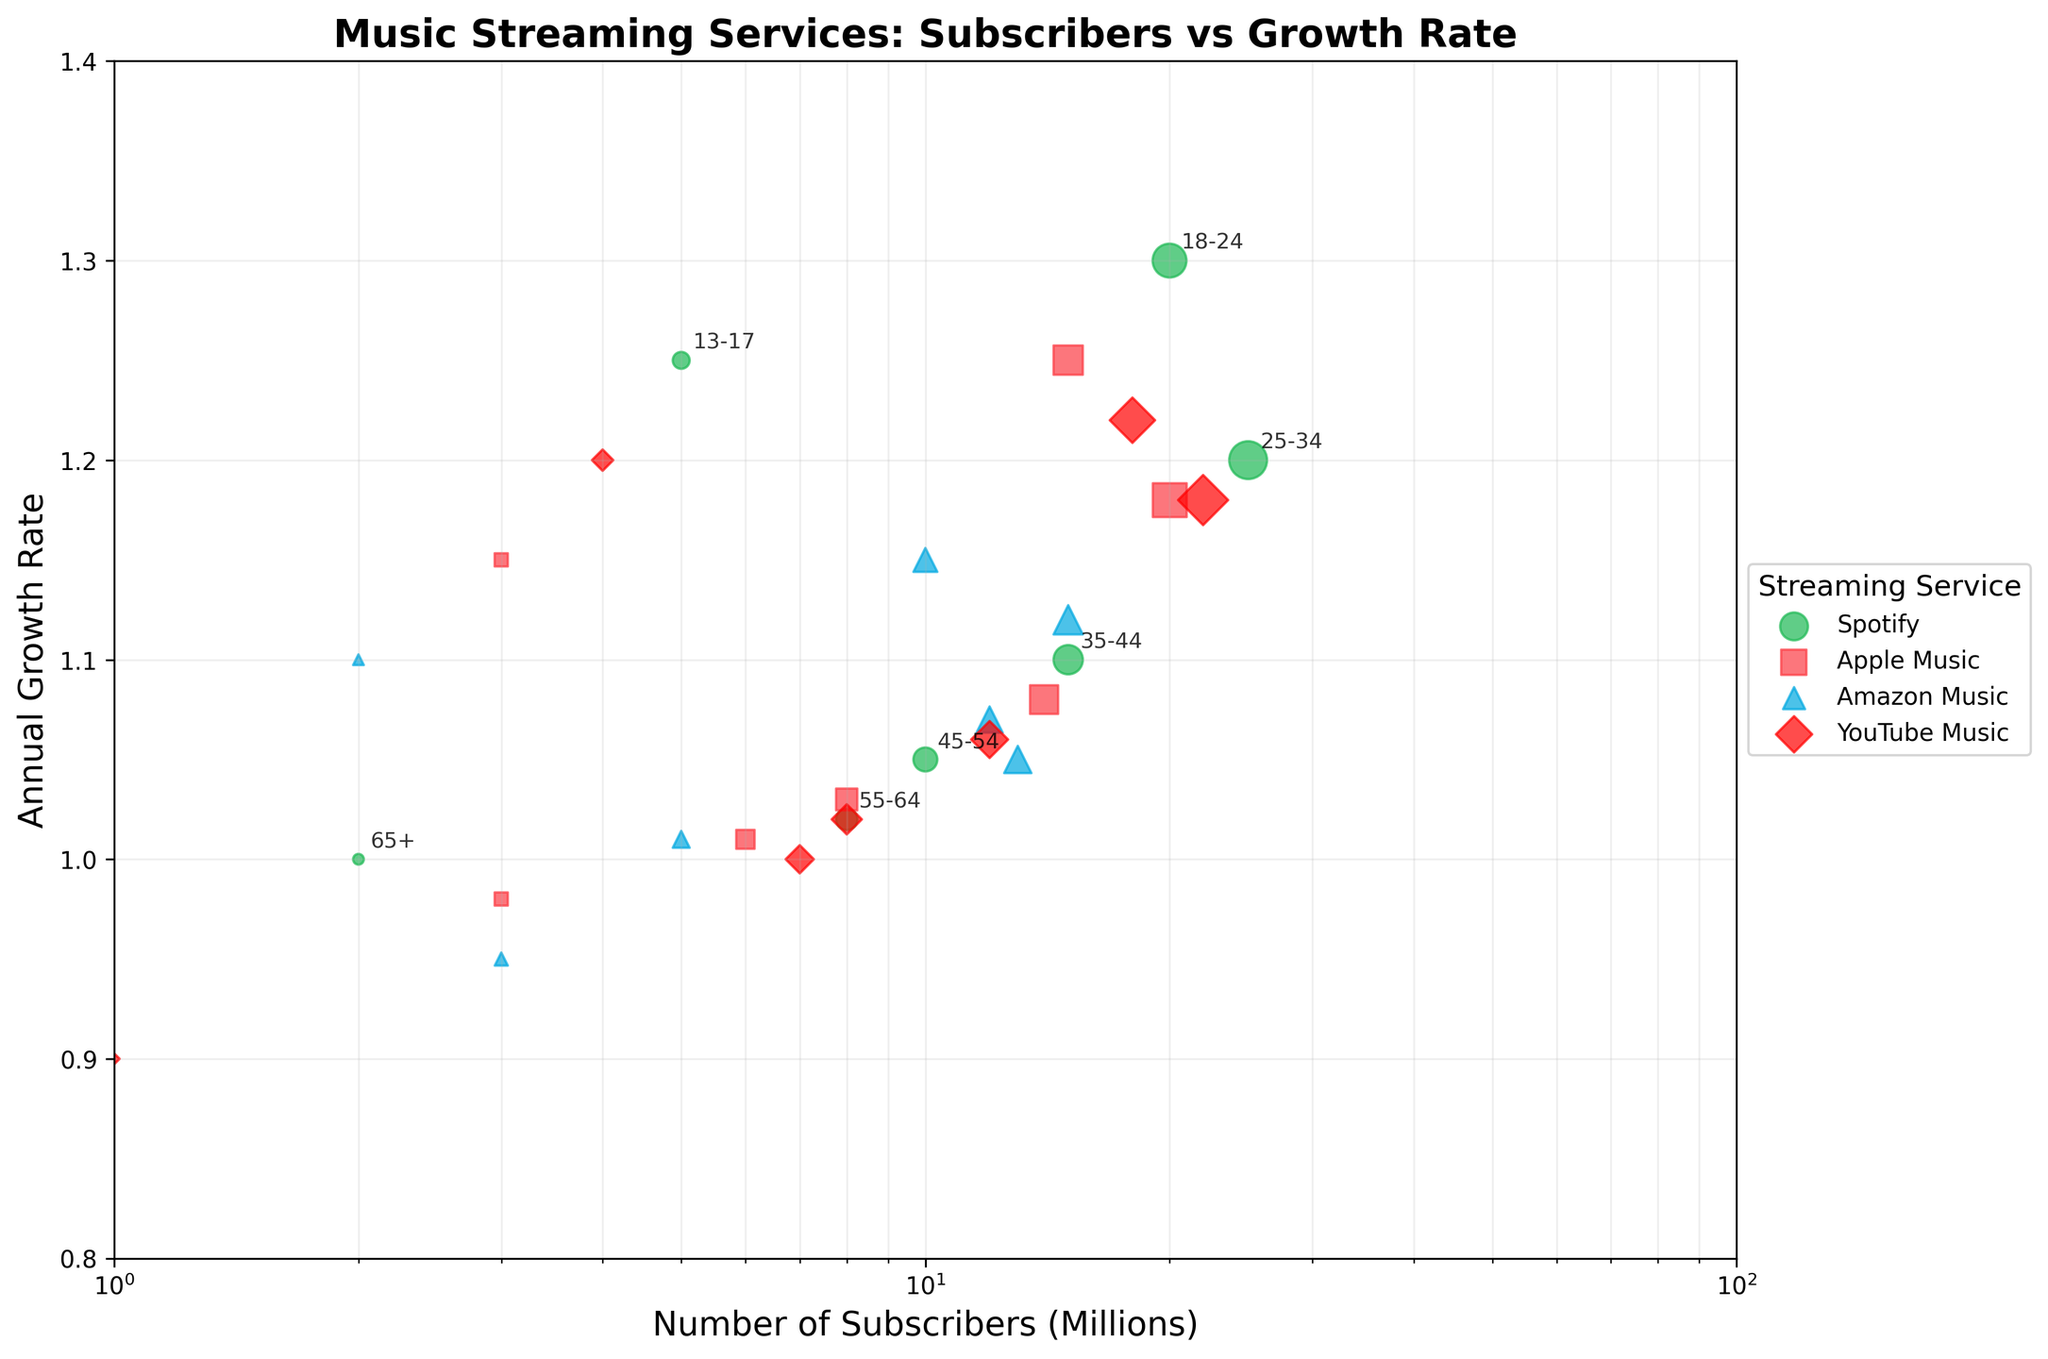How many Age Groups are represented in the scatter plot? From examining the figure, count the number of unique points, each annotated with an Age Group label. Each Age Group has one unique data point for Spotify.
Answer: 7 Which music streaming service has the highest growth rate? Look at the y-axis positions of the data points. The point highest on the axis shows the highest growth rate. Compare the growth rates for each service.
Answer: Spotify What is the annual growth rate of Spotify for the 18-24 age group? Find the data point for the 18-24 age group and look at the y-axis value for Spotify.
Answer: 1.30 How do the growth rates of Apple Music and YouTube Music compare for the 35-44 age group? Locate the data point for the 35-44 age group for both Apple Music and YouTube Music. Compare their y-axis values.
Answer: Apple Music: 1.08, YouTube Music: 1.06 What is the trend in the number of Spotify subscribers as age increases? Track the x-axis values for Spotify across different age groups from youngest to oldest, observing whether the values increase or decrease.
Answer: Decreases Which age group has the lowest growth rate for YouTube Music, and what is that rate? Compare the y-axis values of the YouTube Music data points across all age groups and identify the lowest point.
Answer: 65+, 0.90 For which age group is there the largest discrepancy between the number of subscribers for Spotify and Apple Music? Subtract Apple Music subscribers from Spotify subscribers for each age group and identify the largest difference.
Answer: 18-24 Is there an age group that has more Amazon Music subscribers than Spotify subscribers? Compare the x-axis values for Amazon Music versus Spotify for all age groups.
Answer: No Which age group has the closest number of subscribers across all four streaming services? Compare the x-axis values for all four services within each age group and find the age group with the smallest range.
Answer: 35-44 